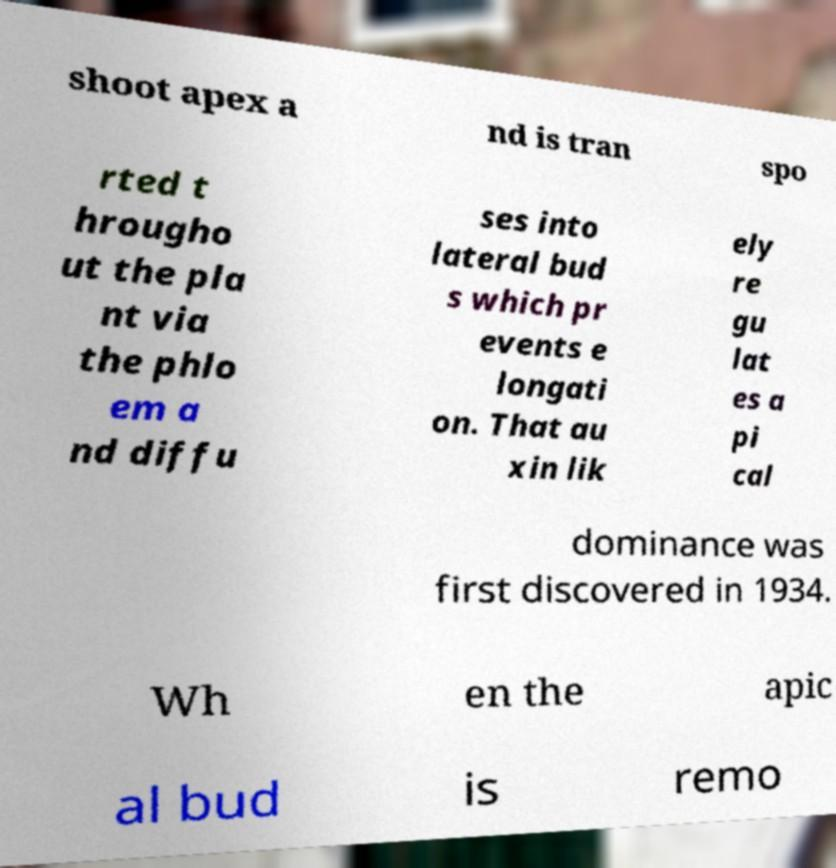Can you accurately transcribe the text from the provided image for me? shoot apex a nd is tran spo rted t hrougho ut the pla nt via the phlo em a nd diffu ses into lateral bud s which pr events e longati on. That au xin lik ely re gu lat es a pi cal dominance was first discovered in 1934. Wh en the apic al bud is remo 